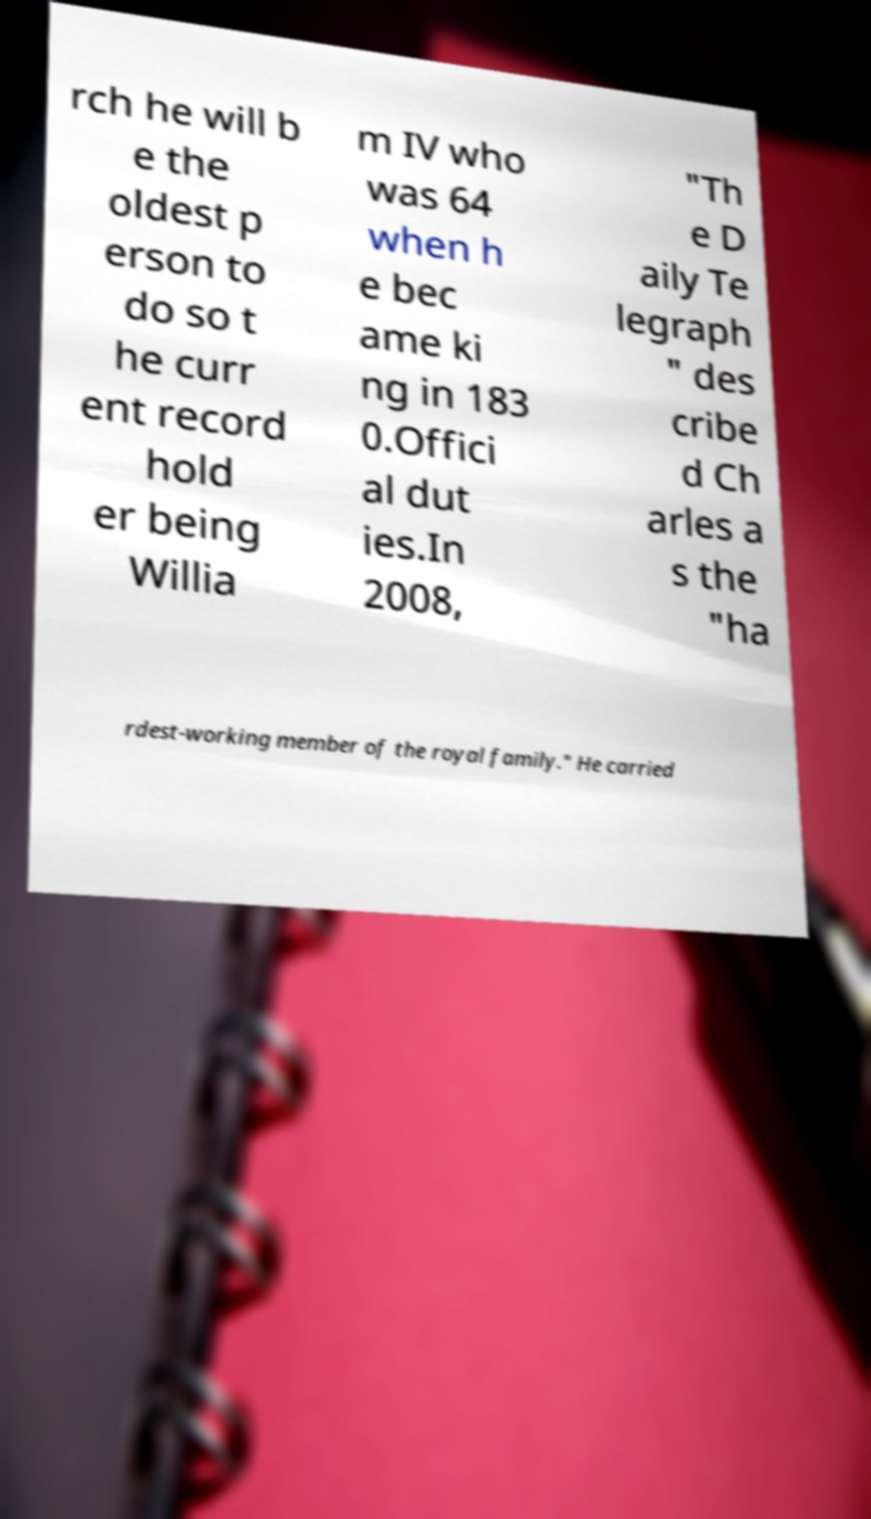Please identify and transcribe the text found in this image. rch he will b e the oldest p erson to do so t he curr ent record hold er being Willia m IV who was 64 when h e bec ame ki ng in 183 0.Offici al dut ies.In 2008, "Th e D aily Te legraph " des cribe d Ch arles a s the "ha rdest-working member of the royal family." He carried 